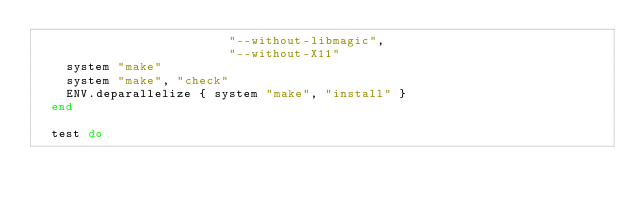Convert code to text. <code><loc_0><loc_0><loc_500><loc_500><_Ruby_>                          "--without-libmagic",
                          "--without-X11"
    system "make"
    system "make", "check"
    ENV.deparallelize { system "make", "install" }
  end

  test do</code> 